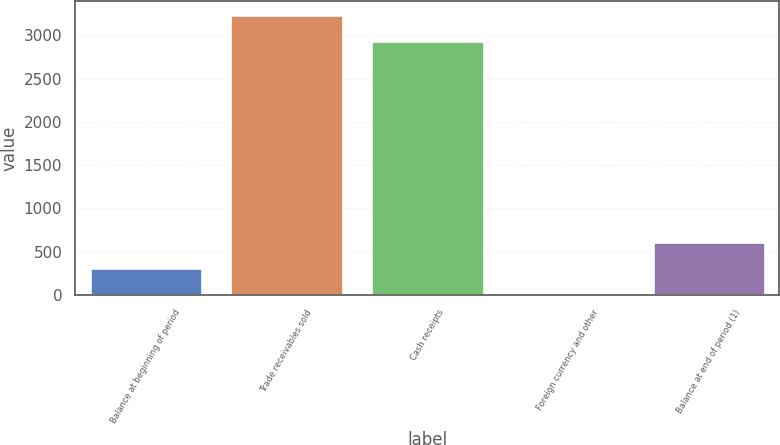<chart> <loc_0><loc_0><loc_500><loc_500><bar_chart><fcel>Balance at beginning of period<fcel>Trade receivables sold<fcel>Cash receipts<fcel>Foreign currency and other<fcel>Balance at end of period (1)<nl><fcel>307.8<fcel>3231.8<fcel>2931<fcel>7<fcel>608.6<nl></chart> 